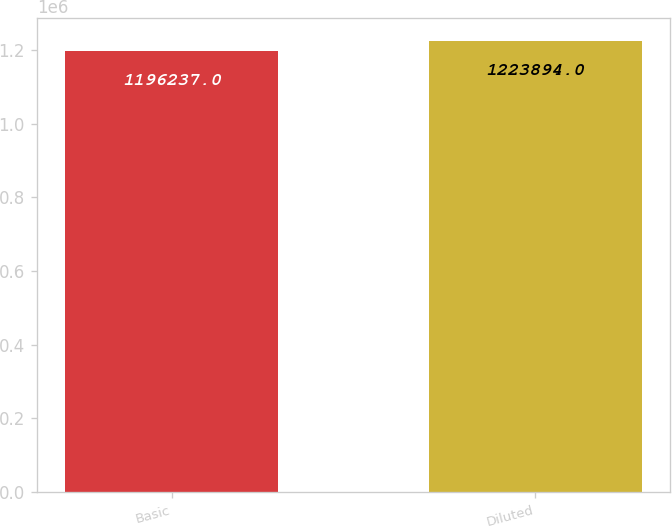Convert chart. <chart><loc_0><loc_0><loc_500><loc_500><bar_chart><fcel>Basic<fcel>Diluted<nl><fcel>1.19624e+06<fcel>1.22389e+06<nl></chart> 